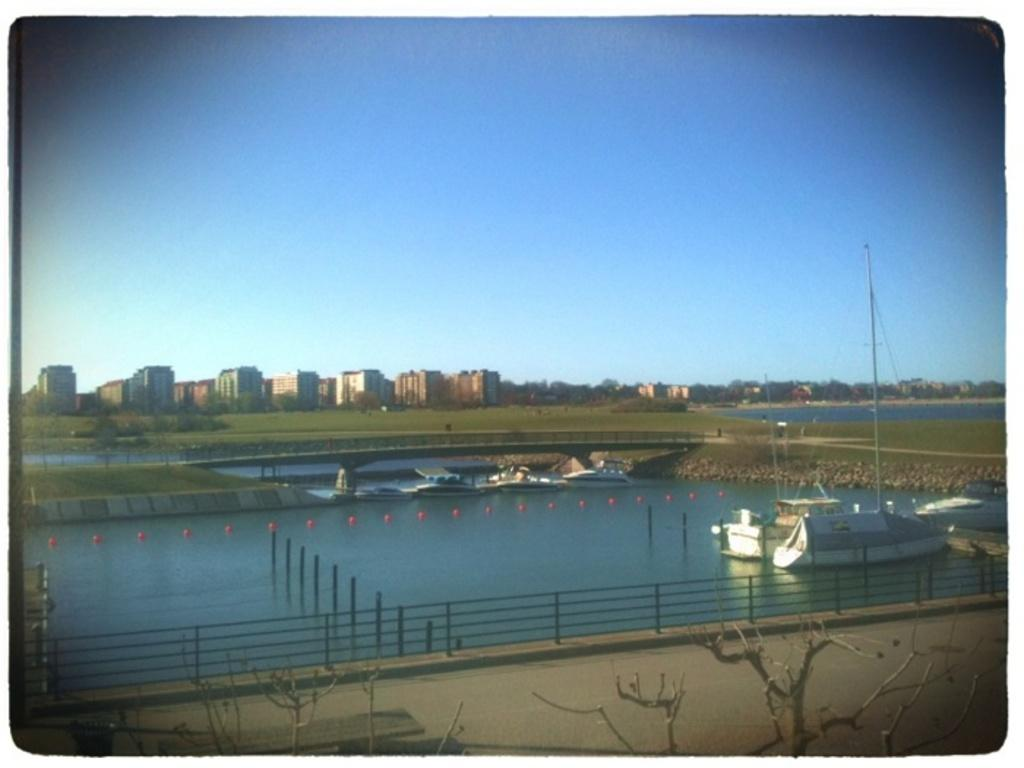What is happening in the image? There are boats on water in the image. What structures can be seen in the image? There are poles, a fence, and buildings visible in the image. What type of path is present in the image? There is a path in the image. What natural elements are present in the image? There are trees and the sky visible in the image. What type of liquid is being used to take the picture in the image? There is no camera or liquid present in the image; it is a scene of boats on water with various structures and natural elements. Is there a camp visible in the image? There is no camp present in the image. 